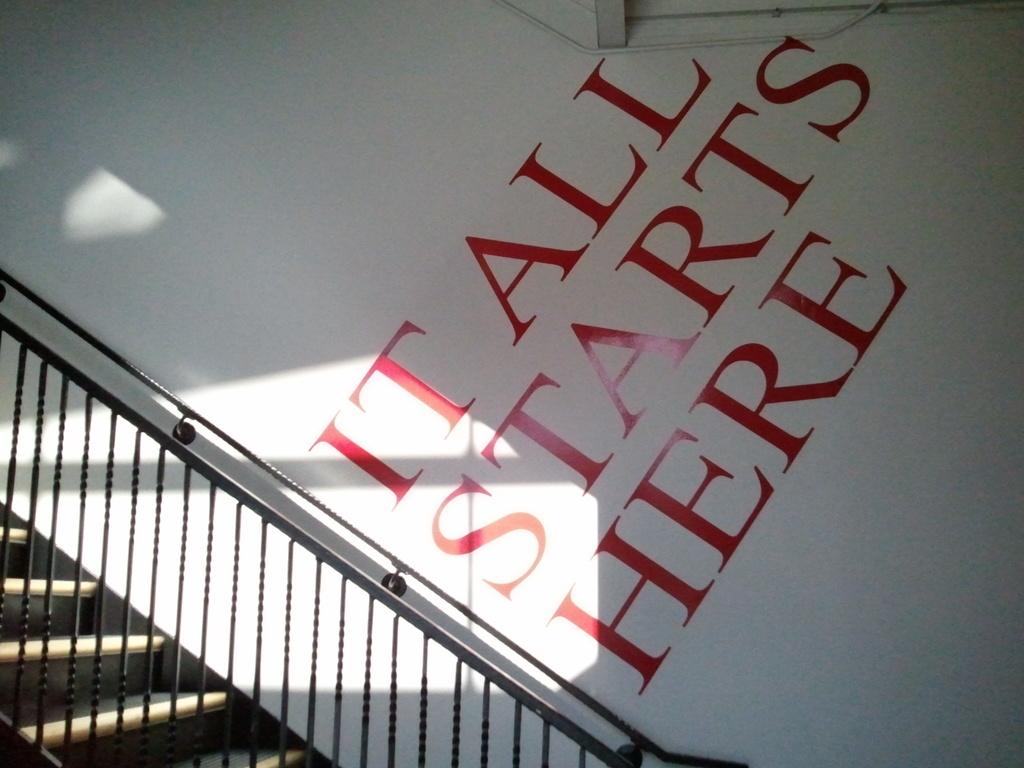Where was the image taken? The image is taken indoors. What can be seen in the background of the image? There is a wall in the background of the image. What is written or depicted on the wall? There is text on the wall. What architectural feature is present on the left side of the image? There is a railing on the left side of the image. How many stairs are visible in the image? There are a few stairs in the image. What type of mouth is visible on the wall in the image? There is no mouth present on the wall in the image. How much debt is represented by the text on the wall in the image? The text on the wall does not represent any debt; it is simply text. 